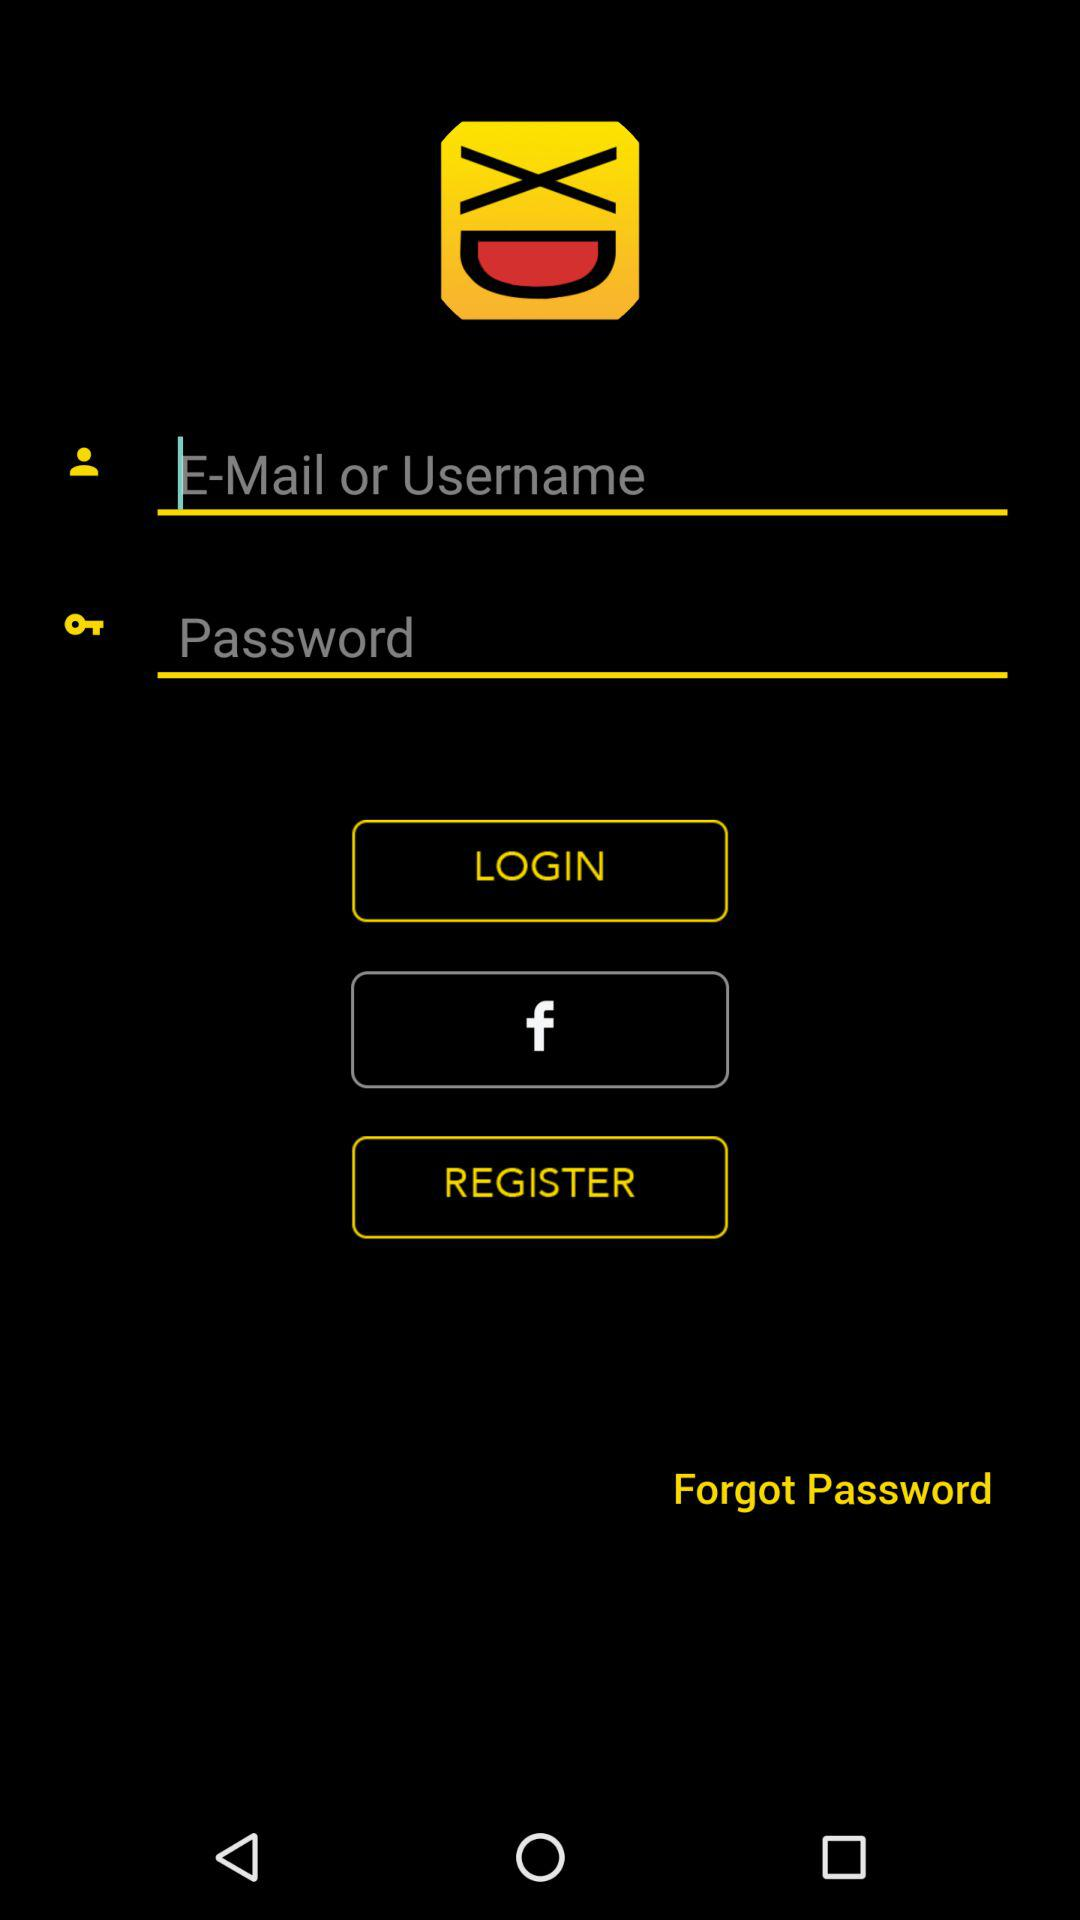How many inputs are there for logging in?
Answer the question using a single word or phrase. 2 